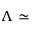<formula> <loc_0><loc_0><loc_500><loc_500>\Lambda \simeq</formula> 